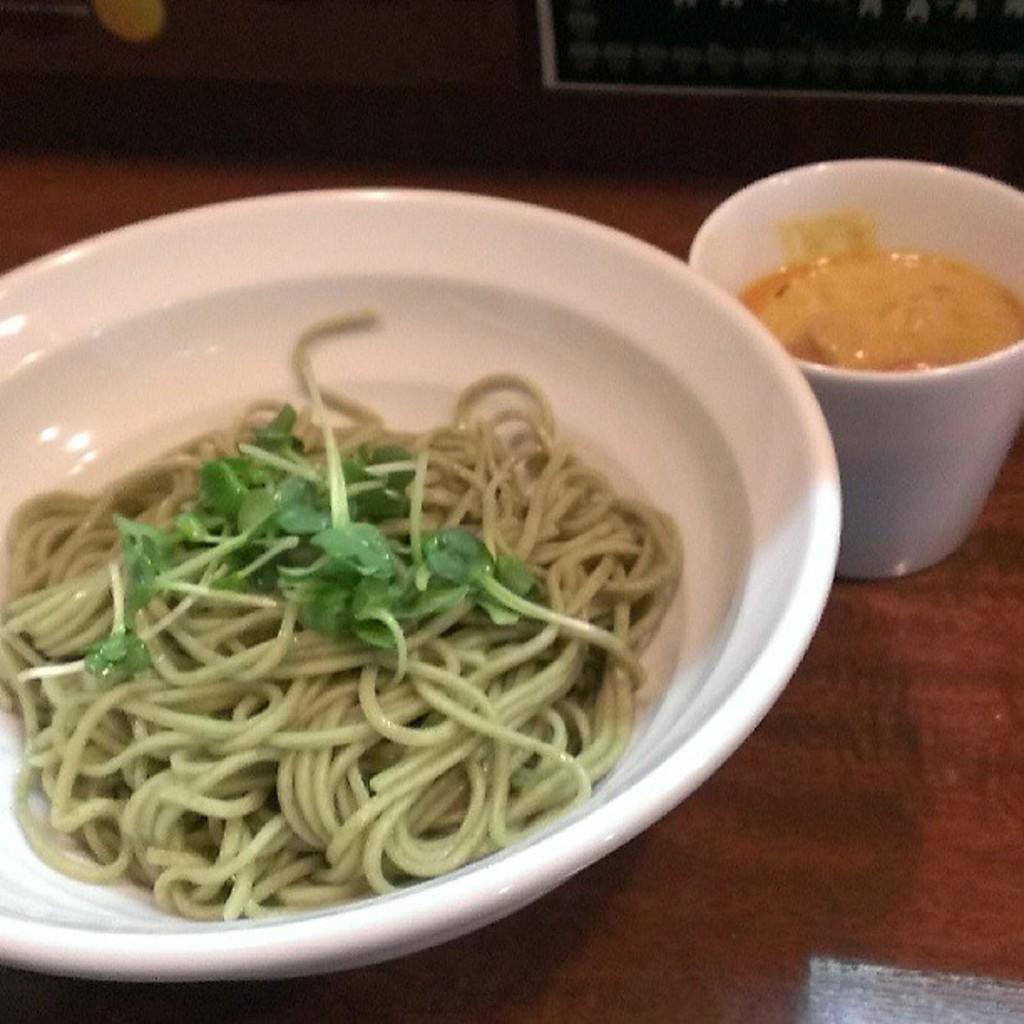Can you describe this image briefly? In the foreground of this image, there are noodles and leafy vegetables in a white bowl. Beside it, there is a white cup on a wooden surface and the background image is not clear. 